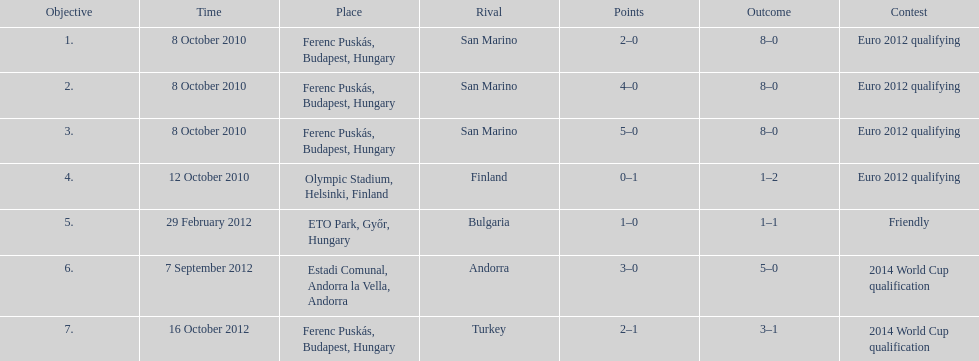Szalai scored only one more international goal against all other countries put together than he did against what one country? San Marino. 